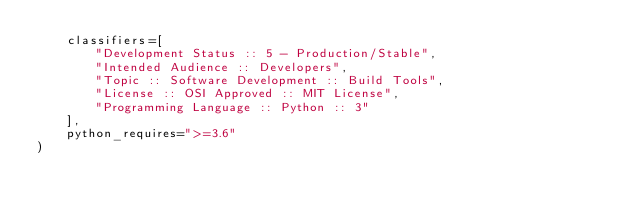<code> <loc_0><loc_0><loc_500><loc_500><_Python_>    classifiers=[
        "Development Status :: 5 - Production/Stable",
        "Intended Audience :: Developers", 
        "Topic :: Software Development :: Build Tools",
        "License :: OSI Approved :: MIT License",
        "Programming Language :: Python :: 3"
    ],
    python_requires=">=3.6"
)</code> 